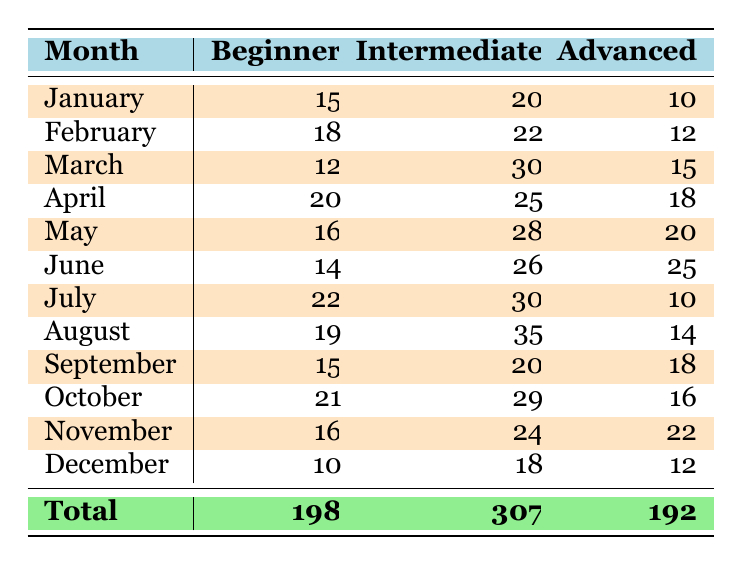What is the total attendance for beginners in March? In March, the table shows that there were 12 beginner attendees. Since the question specifically asks for March, we refer directly to that month's data.
Answer: 12 What month had the highest number of intermediate attendees? By comparing the numbers of intermediate attendees across all months, we see that August had the highest with 35 attendees.
Answer: August What is the average number of advanced attendees per month? The total number of advanced attendees across all months is 192. There are 12 months, so the average is 192 divided by 12, which equals 16.
Answer: 16 Did more beginner attendees show up in June than in December? In June, there were 14 beginner attendees, whereas in December there were 10. Since 14 is greater than 10, the statement is true.
Answer: Yes What is the combined total of beginner and advanced attendees in April? In April, there were 20 beginner and 18 advanced attendees. Adding them together gives us 20 plus 18, resulting in a total of 38 attendees.
Answer: 38 Which month had the fewest total attendees overall? To find the month with the fewest total attendees, we need to sum the attendees of each skill level for each month. The calculations for each month show that December, with a total of 40 attendees (10 beginner + 18 intermediate + 12 advanced), had the least overall attendance.
Answer: December How many more intermediate attendees were there in July compared to May? In July, there were 30 intermediate attendees, and in May there were 28. The difference is 30 minus 28, which equals 2.
Answer: 2 Which skill level has the highest total attendance across all months? To determine this, we look at the total attendance numbers: Beginners total 198, Intermediate total 307, and Advanced total 192. Therefore, Intermediate, with 307 attendees, has the highest total.
Answer: Intermediate What is the total number of attendees for all skill levels in October? In October, the numbers are 21 beginners, 29 intermediate, and 16 advanced. Adding them together gives us 21 plus 29 plus 16, which equals 66 attendees in total for that month.
Answer: 66 